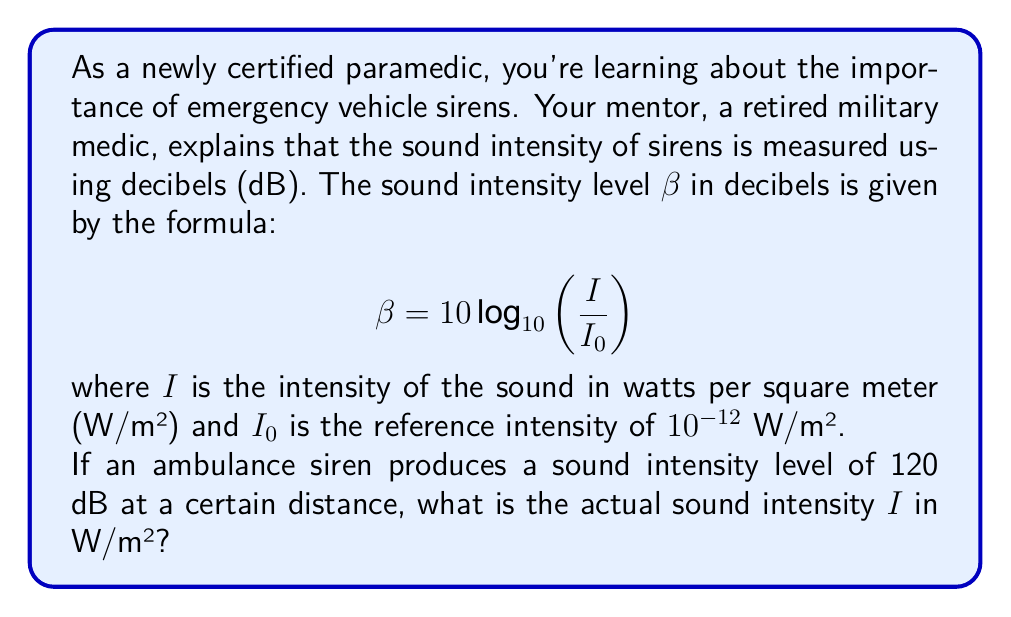Help me with this question. Let's approach this step-by-step:

1) We're given the formula for sound intensity level in decibels:
   $$ \beta = 10 \log_{10}\left(\frac{I}{I_0}\right) $$

2) We know that:
   - $\beta = 120$ dB (the sound intensity level of the siren)
   - $I_0 = 10^{-12}$ W/m² (the reference intensity)

3) Let's substitute these values into the formula:
   $$ 120 = 10 \log_{10}\left(\frac{I}{10^{-12}}\right) $$

4) To solve for $I$, let's first divide both sides by 10:
   $$ 12 = \log_{10}\left(\frac{I}{10^{-12}}\right) $$

5) Now, we can apply the inverse operation (10 to the power of both sides):
   $$ 10^{12} = \frac{I}{10^{-12}} $$

6) Multiply both sides by $10^{-12}$:
   $$ I = 10^{12} \cdot 10^{-12} = 1 \text{ W/m²} $$

Therefore, the actual sound intensity $I$ is 1 W/m².
Answer: $I = 1$ W/m² 